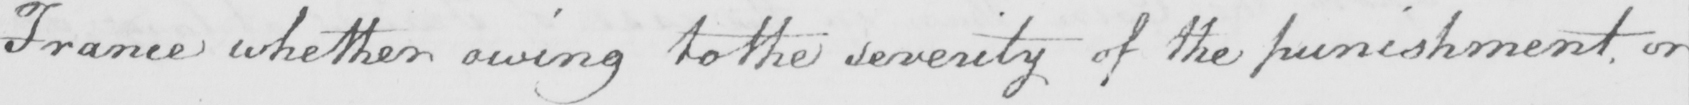Transcribe the text shown in this historical manuscript line. France whether owing to the severity of the punishment , or 